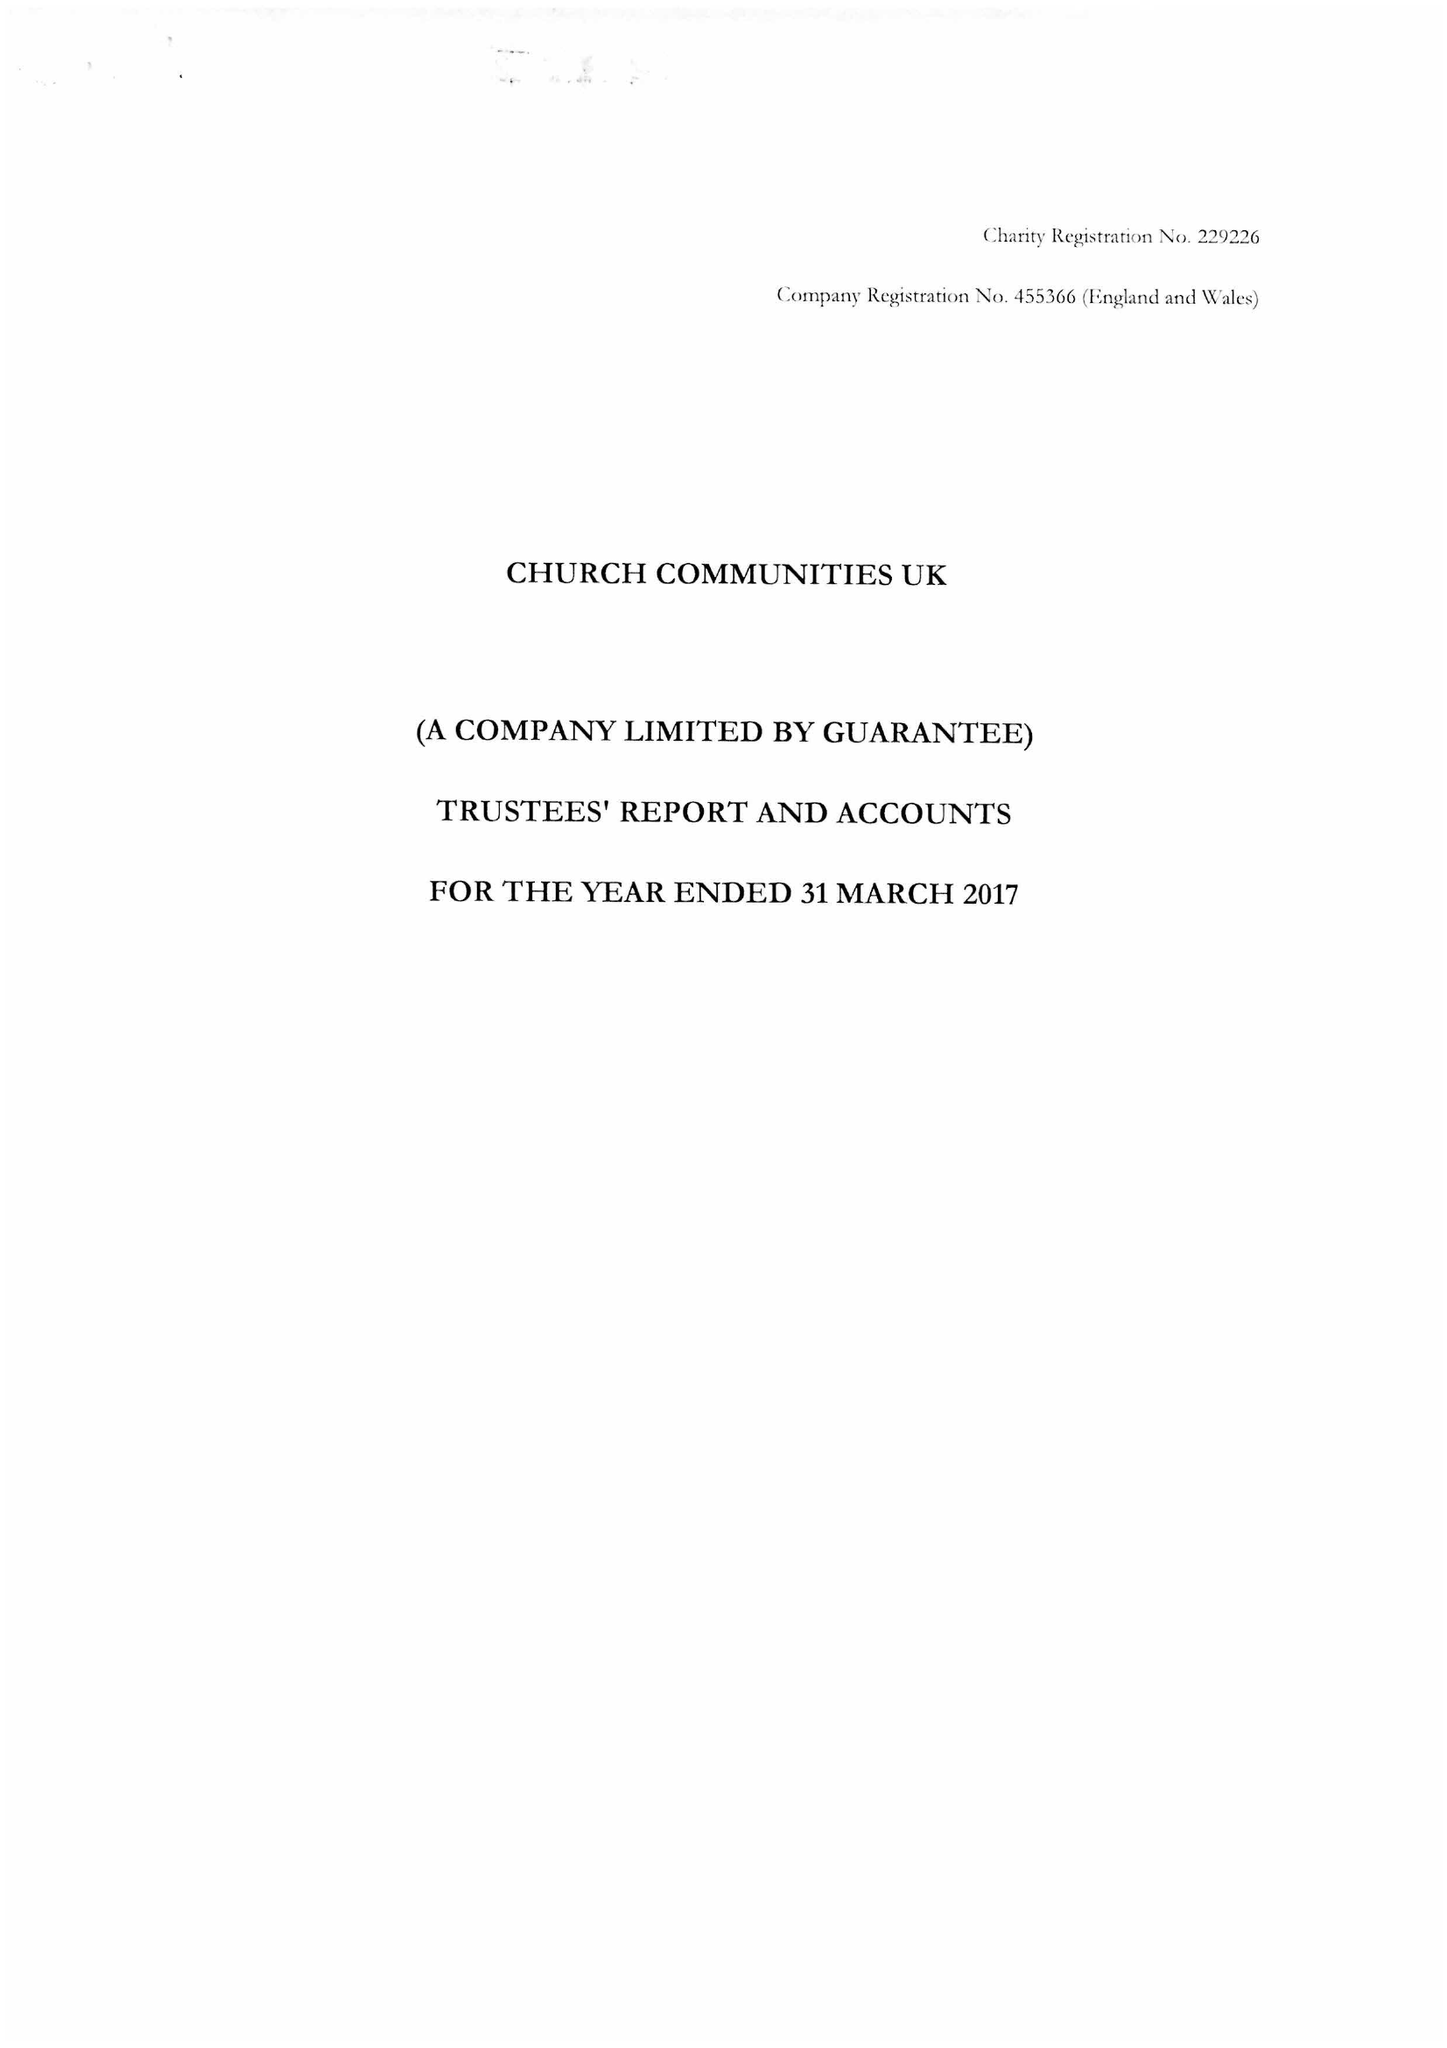What is the value for the income_annually_in_british_pounds?
Answer the question using a single word or phrase. 24010992.00 